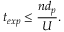Convert formula to latex. <formula><loc_0><loc_0><loc_500><loc_500>t _ { e x p } \leq \frac { n d _ { p } } { U } .</formula> 